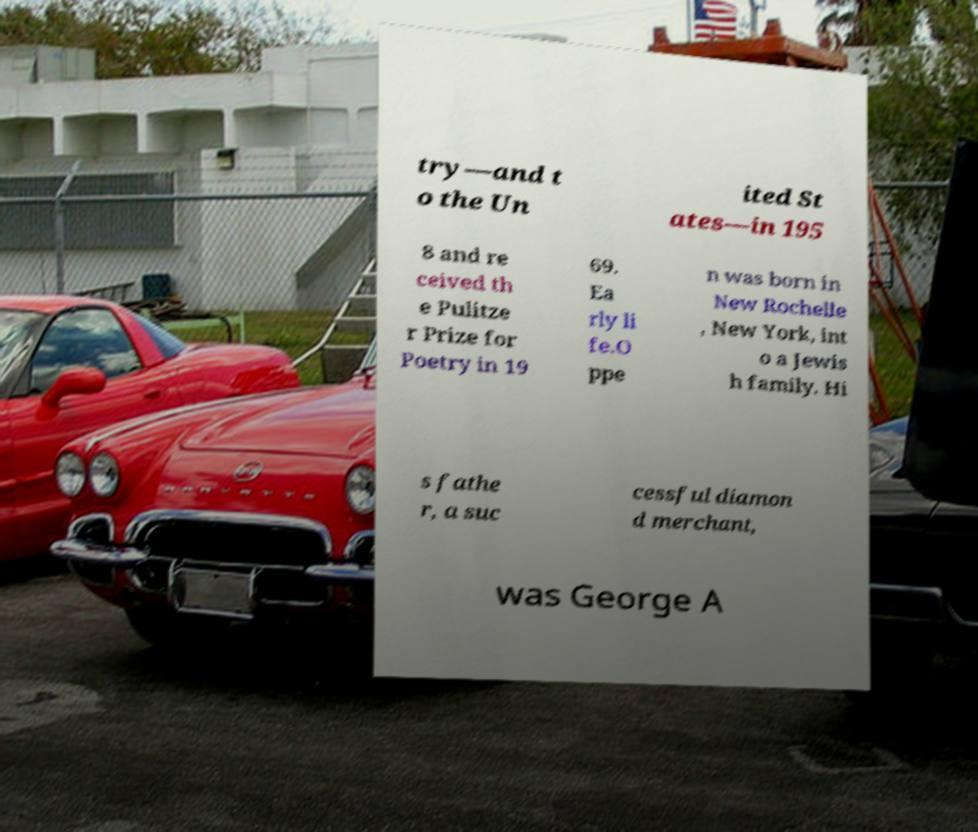Can you read and provide the text displayed in the image?This photo seems to have some interesting text. Can you extract and type it out for me? try—and t o the Un ited St ates—in 195 8 and re ceived th e Pulitze r Prize for Poetry in 19 69. Ea rly li fe.O ppe n was born in New Rochelle , New York, int o a Jewis h family. Hi s fathe r, a suc cessful diamon d merchant, was George A 